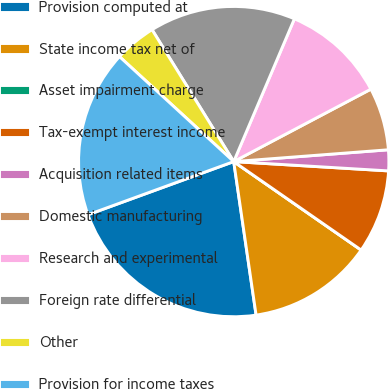Convert chart to OTSL. <chart><loc_0><loc_0><loc_500><loc_500><pie_chart><fcel>Provision computed at<fcel>State income tax net of<fcel>Asset impairment charge<fcel>Tax-exempt interest income<fcel>Acquisition related items<fcel>Domestic manufacturing<fcel>Research and experimental<fcel>Foreign rate differential<fcel>Other<fcel>Provision for income taxes<nl><fcel>21.74%<fcel>13.04%<fcel>0.0%<fcel>8.7%<fcel>2.17%<fcel>6.52%<fcel>10.87%<fcel>15.22%<fcel>4.35%<fcel>17.39%<nl></chart> 